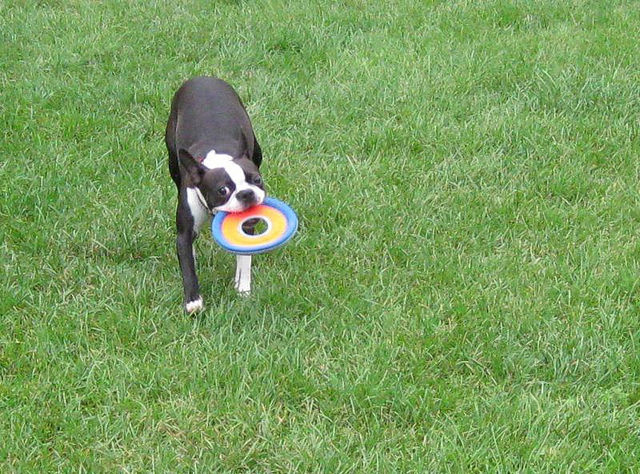<image>What image is on the frisbee? There is no image on the frisbee in the picture. It might be just colors or shades. What image is on the frisbee? There is no image on the frisbee. 